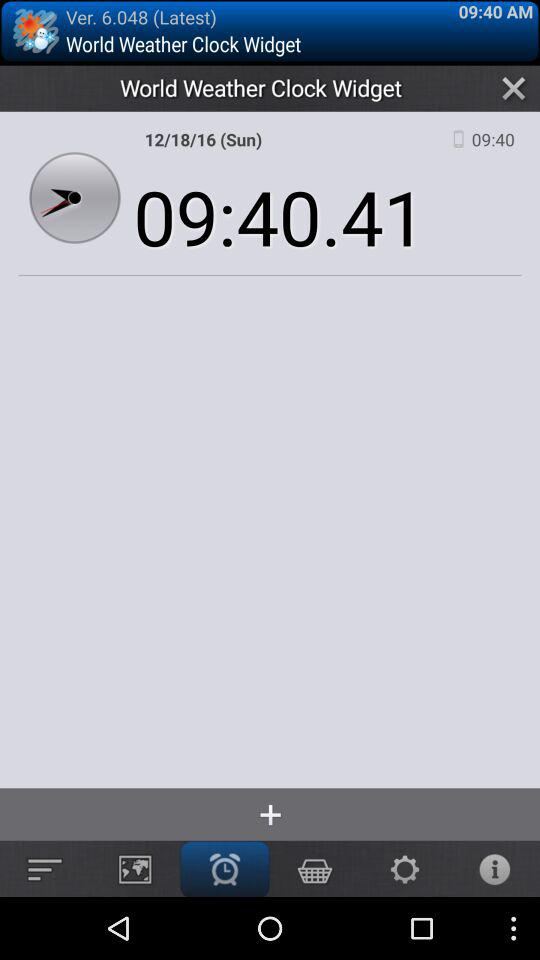What version of the application is being used? The version of the application being used is 6.048. 